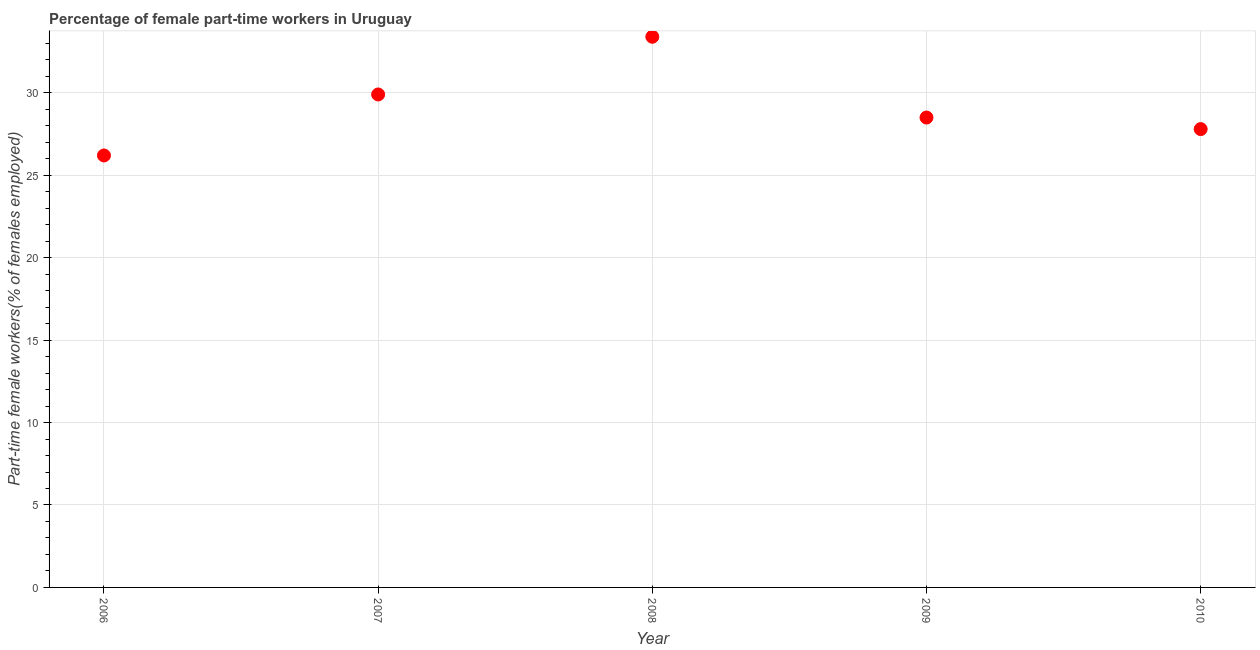What is the percentage of part-time female workers in 2006?
Offer a terse response. 26.2. Across all years, what is the maximum percentage of part-time female workers?
Offer a very short reply. 33.4. Across all years, what is the minimum percentage of part-time female workers?
Your response must be concise. 26.2. In which year was the percentage of part-time female workers minimum?
Your answer should be compact. 2006. What is the sum of the percentage of part-time female workers?
Keep it short and to the point. 145.8. What is the difference between the percentage of part-time female workers in 2006 and 2007?
Provide a short and direct response. -3.7. What is the average percentage of part-time female workers per year?
Offer a very short reply. 29.16. In how many years, is the percentage of part-time female workers greater than 8 %?
Provide a succinct answer. 5. What is the ratio of the percentage of part-time female workers in 2006 to that in 2010?
Offer a very short reply. 0.94. Is the percentage of part-time female workers in 2007 less than that in 2010?
Offer a very short reply. No. What is the difference between the highest and the second highest percentage of part-time female workers?
Give a very brief answer. 3.5. What is the difference between the highest and the lowest percentage of part-time female workers?
Keep it short and to the point. 7.2. In how many years, is the percentage of part-time female workers greater than the average percentage of part-time female workers taken over all years?
Offer a very short reply. 2. Does the percentage of part-time female workers monotonically increase over the years?
Give a very brief answer. No. How many dotlines are there?
Your answer should be very brief. 1. How many years are there in the graph?
Ensure brevity in your answer.  5. What is the difference between two consecutive major ticks on the Y-axis?
Ensure brevity in your answer.  5. Are the values on the major ticks of Y-axis written in scientific E-notation?
Your response must be concise. No. Does the graph contain grids?
Offer a very short reply. Yes. What is the title of the graph?
Offer a terse response. Percentage of female part-time workers in Uruguay. What is the label or title of the X-axis?
Make the answer very short. Year. What is the label or title of the Y-axis?
Provide a succinct answer. Part-time female workers(% of females employed). What is the Part-time female workers(% of females employed) in 2006?
Your answer should be very brief. 26.2. What is the Part-time female workers(% of females employed) in 2007?
Ensure brevity in your answer.  29.9. What is the Part-time female workers(% of females employed) in 2008?
Offer a very short reply. 33.4. What is the Part-time female workers(% of females employed) in 2010?
Give a very brief answer. 27.8. What is the difference between the Part-time female workers(% of females employed) in 2006 and 2009?
Keep it short and to the point. -2.3. What is the difference between the Part-time female workers(% of females employed) in 2006 and 2010?
Your response must be concise. -1.6. What is the difference between the Part-time female workers(% of females employed) in 2007 and 2009?
Keep it short and to the point. 1.4. What is the difference between the Part-time female workers(% of females employed) in 2007 and 2010?
Make the answer very short. 2.1. What is the difference between the Part-time female workers(% of females employed) in 2008 and 2009?
Keep it short and to the point. 4.9. What is the difference between the Part-time female workers(% of females employed) in 2008 and 2010?
Your answer should be very brief. 5.6. What is the difference between the Part-time female workers(% of females employed) in 2009 and 2010?
Offer a terse response. 0.7. What is the ratio of the Part-time female workers(% of females employed) in 2006 to that in 2007?
Make the answer very short. 0.88. What is the ratio of the Part-time female workers(% of females employed) in 2006 to that in 2008?
Offer a terse response. 0.78. What is the ratio of the Part-time female workers(% of females employed) in 2006 to that in 2009?
Make the answer very short. 0.92. What is the ratio of the Part-time female workers(% of females employed) in 2006 to that in 2010?
Ensure brevity in your answer.  0.94. What is the ratio of the Part-time female workers(% of females employed) in 2007 to that in 2008?
Keep it short and to the point. 0.9. What is the ratio of the Part-time female workers(% of females employed) in 2007 to that in 2009?
Provide a succinct answer. 1.05. What is the ratio of the Part-time female workers(% of females employed) in 2007 to that in 2010?
Give a very brief answer. 1.08. What is the ratio of the Part-time female workers(% of females employed) in 2008 to that in 2009?
Offer a terse response. 1.17. What is the ratio of the Part-time female workers(% of females employed) in 2008 to that in 2010?
Provide a short and direct response. 1.2. What is the ratio of the Part-time female workers(% of females employed) in 2009 to that in 2010?
Your response must be concise. 1.02. 